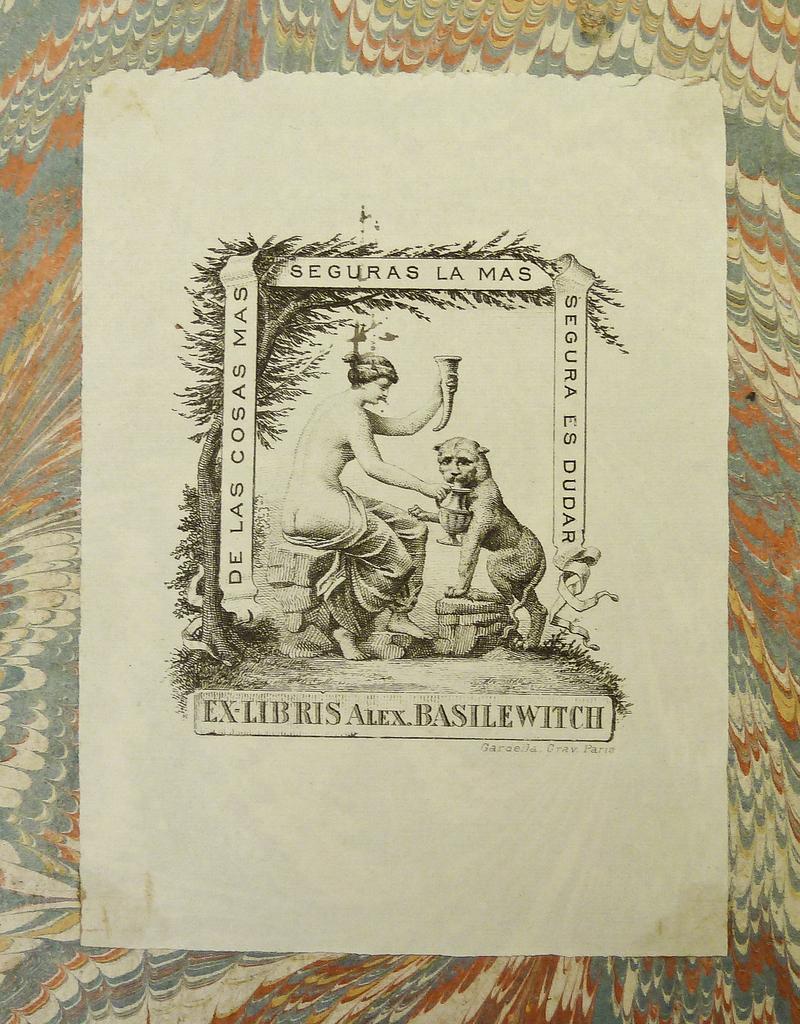Is the language shown latin?
Your answer should be compact. Yes. What is the title of the work?
Offer a very short reply. Seguars la mas. 